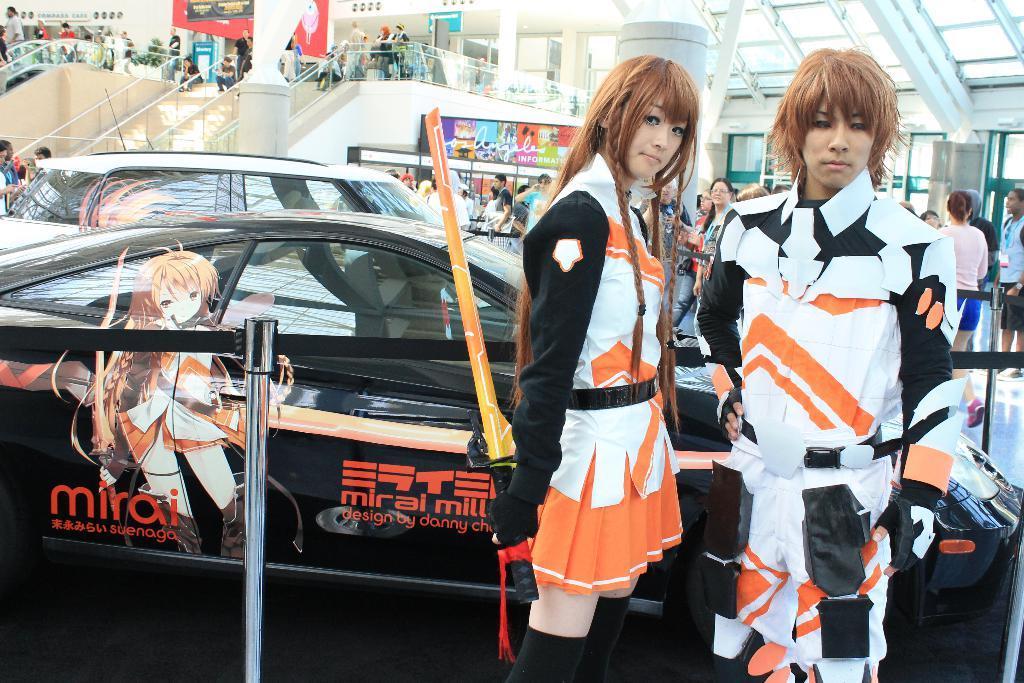Could you give a brief overview of what you see in this image? It looks like a mall and people are moving around the mall and in the front there are two people standing in front of the cars and it looks like some expo. 